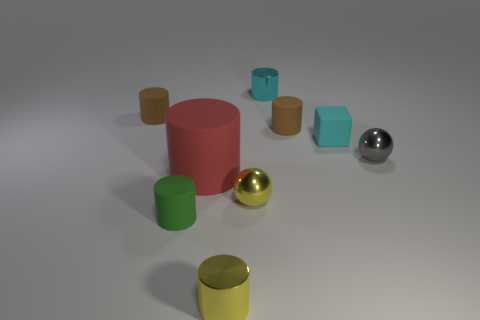Subtract all small cyan cylinders. How many cylinders are left? 5 Subtract all blue cubes. How many brown cylinders are left? 2 Subtract all brown cylinders. How many cylinders are left? 4 Add 1 tiny cyan matte objects. How many objects exist? 10 Subtract all brown cylinders. Subtract all green blocks. How many cylinders are left? 4 Subtract all cylinders. How many objects are left? 3 Subtract 1 cyan cubes. How many objects are left? 8 Subtract all red matte objects. Subtract all matte blocks. How many objects are left? 7 Add 2 tiny cyan rubber cubes. How many tiny cyan rubber cubes are left? 3 Add 5 matte cylinders. How many matte cylinders exist? 9 